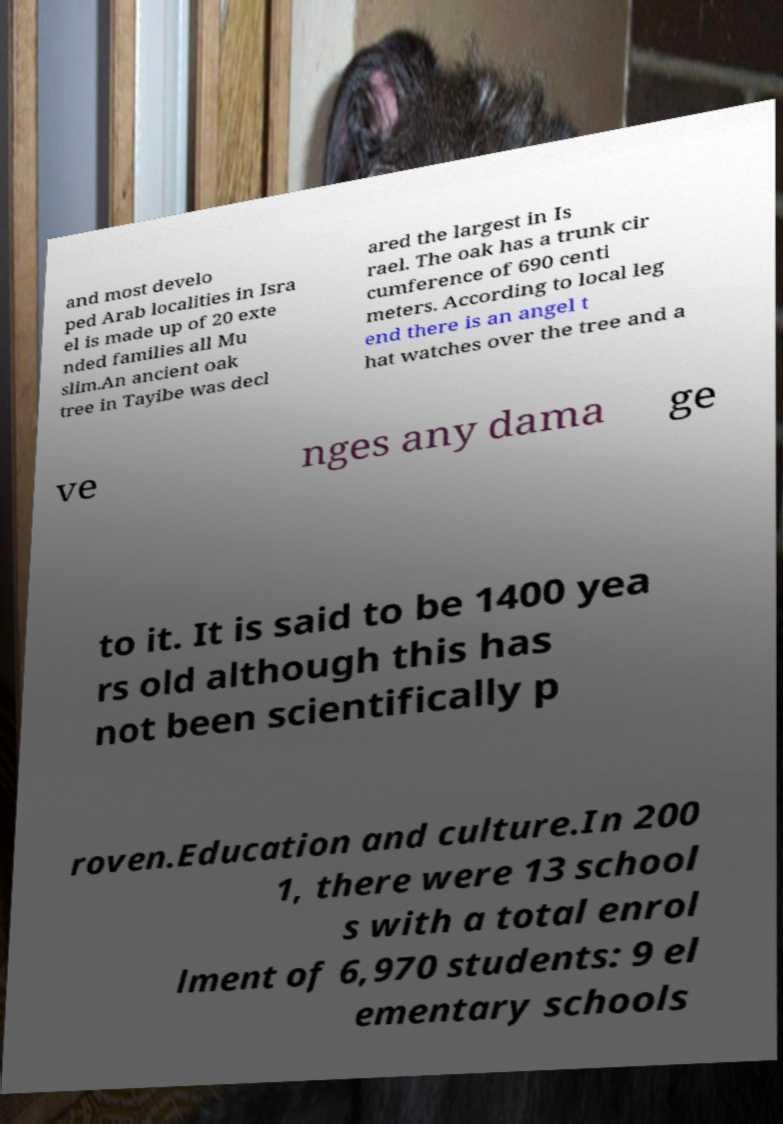For documentation purposes, I need the text within this image transcribed. Could you provide that? and most develo ped Arab localities in Isra el is made up of 20 exte nded families all Mu slim.An ancient oak tree in Tayibe was decl ared the largest in Is rael. The oak has a trunk cir cumference of 690 centi meters. According to local leg end there is an angel t hat watches over the tree and a ve nges any dama ge to it. It is said to be 1400 yea rs old although this has not been scientifically p roven.Education and culture.In 200 1, there were 13 school s with a total enrol lment of 6,970 students: 9 el ementary schools 